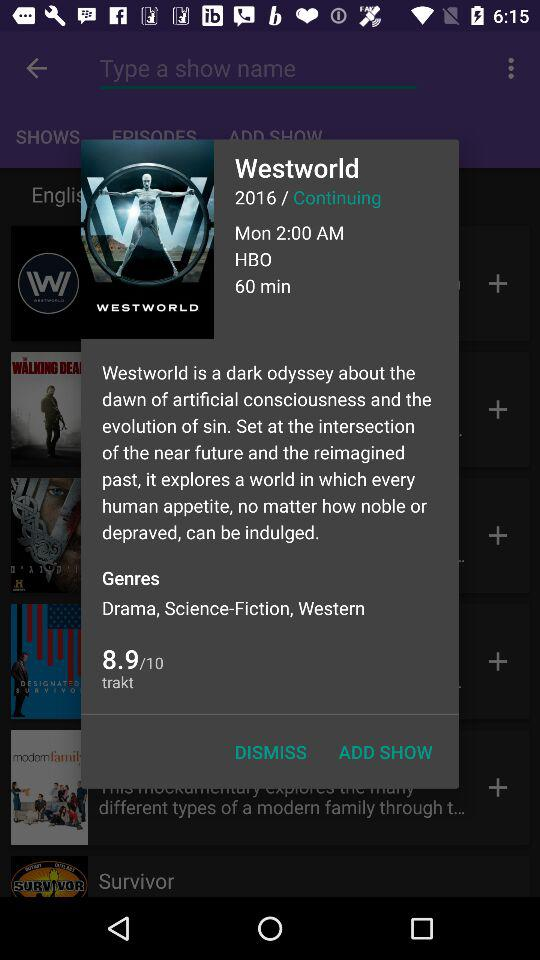How many genres are there?
Answer the question using a single word or phrase. 3 